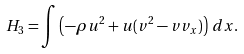Convert formula to latex. <formula><loc_0><loc_0><loc_500><loc_500>H _ { 3 } = \int \left ( - \rho u ^ { 2 } + u ( v ^ { 2 } - v v _ { x } ) \right ) \, d x .</formula> 